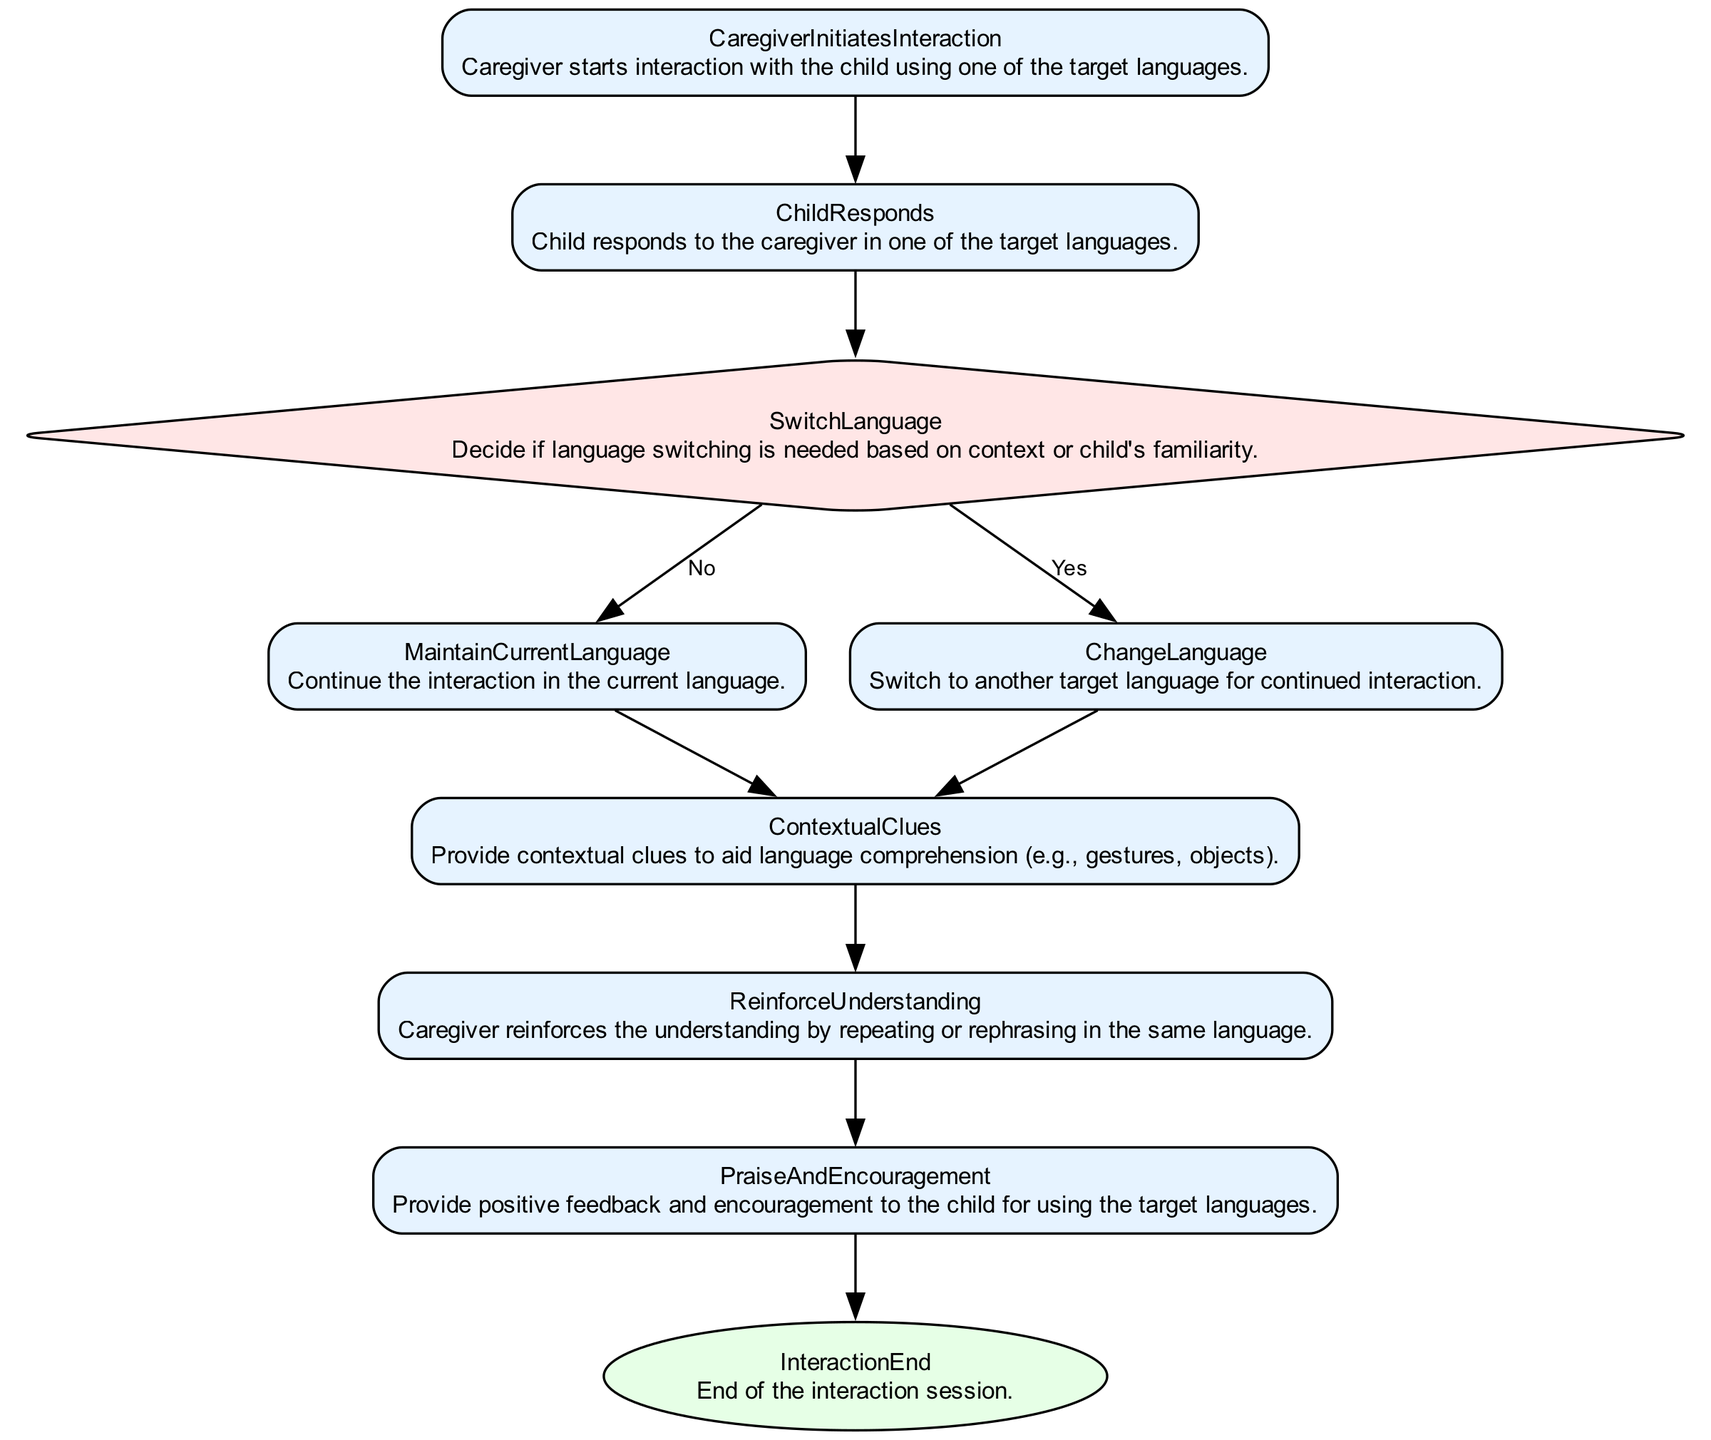What is the first action taken in the interaction? The first action is "CaregiverInitiatesInteraction," which indicates that the caregiver starts the interaction with the child using one of the target languages.
Answer: CaregiverInitiatesInteraction How many action nodes are there in the diagram? There are seven action nodes: CaregiverInitiatesInteraction, ChildResponds, MaintainCurrentLanguage, ChangeLanguage, ContextualClues, ReinforceUnderstanding, and PraiseAndEncouragement.
Answer: Seven What decision does the diagram present after the child responds? After the child responds, the decision presented is "SwitchLanguage," which determines if a language switch is necessary based on the context or the child's familiarity.
Answer: SwitchLanguage If the language switch is needed, what is the next action? If a language switch is determined to be needed (Yes path), the next action is "ChangeLanguage," where the caregiver switches to another target language for interaction.
Answer: ChangeLanguage How does the caregiver reinforce the child's understanding? The caregiver reinforces the understanding by employing the action "ReinforceUnderstanding," which involves repeating or rephrasing in the same language.
Answer: ReinforceUnderstanding What occurs after providing contextual clues? After providing contextual clues, the next action is "ReinforceUnderstanding," meaning the caregiver will reinforce the child's comprehension of the language used.
Answer: ReinforceUnderstanding What action comes directly before the interaction ends? The action that comes directly before the interaction ends is "PraiseAndEncouragement," where the caregiver provides positive feedback for the child's language use.
Answer: PraiseAndEncouragement What is the last node in the diagram? The last node in the diagram is "InteractionEnd," which signifies the conclusion of the interaction session.
Answer: InteractionEnd What happens if the decision is not to switch languages? If the decision is not to switch languages (No path), the action that follows is "MaintainCurrentLanguage," indicating the interaction continues in the current language.
Answer: MaintainCurrentLanguage 